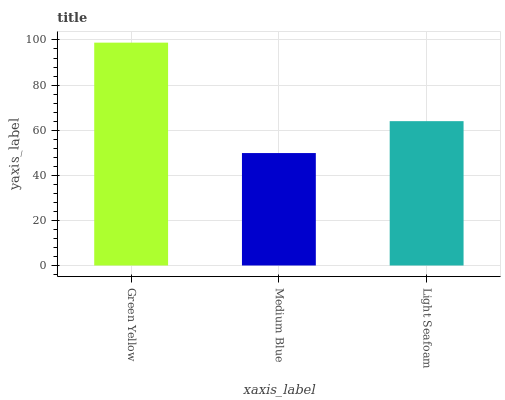Is Light Seafoam the minimum?
Answer yes or no. No. Is Light Seafoam the maximum?
Answer yes or no. No. Is Light Seafoam greater than Medium Blue?
Answer yes or no. Yes. Is Medium Blue less than Light Seafoam?
Answer yes or no. Yes. Is Medium Blue greater than Light Seafoam?
Answer yes or no. No. Is Light Seafoam less than Medium Blue?
Answer yes or no. No. Is Light Seafoam the high median?
Answer yes or no. Yes. Is Light Seafoam the low median?
Answer yes or no. Yes. Is Medium Blue the high median?
Answer yes or no. No. Is Medium Blue the low median?
Answer yes or no. No. 